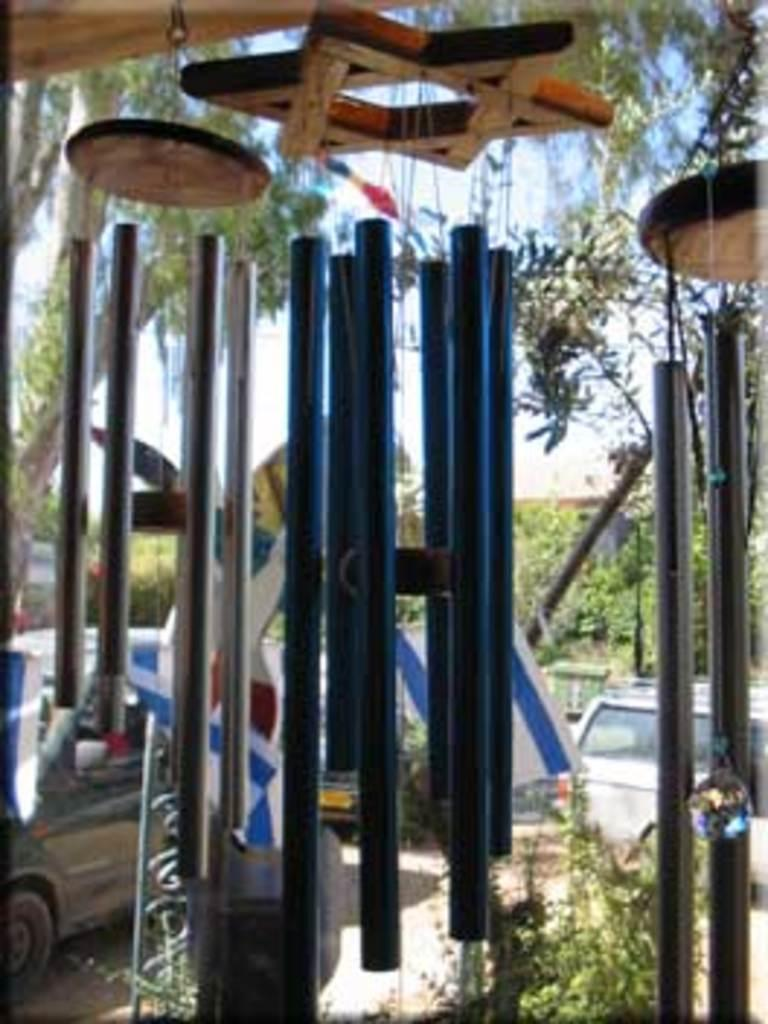What type of material is used for the objects in the image? The wooden objects in the image are made of wood. What are the rods used for in the image? The purpose of the rods in the image is not specified, but they are likely used as part of the wooden objects. Can you describe the other objects in the image? The other objects in the image are not specified, but they are likely related to the wooden objects and rods. What can be seen in the background of the image? In the background of the image, there is a vehicle, plants, trees, and the sky. How many times do the people in the image kiss each other? There are no people visible in the image, so it is not possible to determine if they are kissing or how many times. What type of tray is used to serve the food in the image? There is no food or tray present in the image, so it is not possible to determine if a tray is used or its type. 